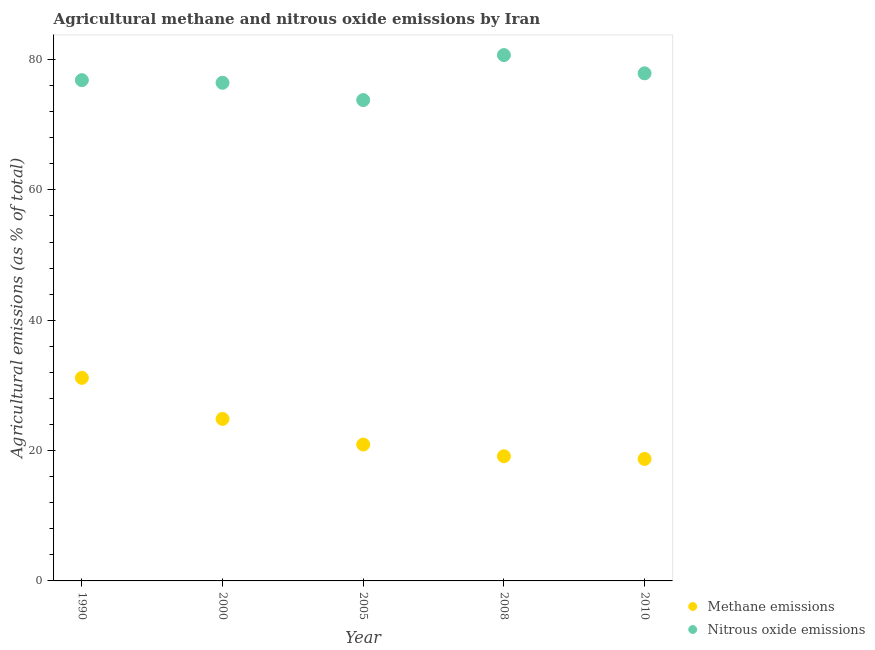What is the amount of nitrous oxide emissions in 2008?
Offer a very short reply. 80.69. Across all years, what is the maximum amount of methane emissions?
Your answer should be compact. 31.16. Across all years, what is the minimum amount of methane emissions?
Your response must be concise. 18.72. What is the total amount of nitrous oxide emissions in the graph?
Ensure brevity in your answer.  385.66. What is the difference between the amount of nitrous oxide emissions in 2008 and that in 2010?
Offer a terse response. 2.8. What is the difference between the amount of methane emissions in 2010 and the amount of nitrous oxide emissions in 2005?
Keep it short and to the point. -55.07. What is the average amount of methane emissions per year?
Your answer should be compact. 22.96. In the year 2005, what is the difference between the amount of methane emissions and amount of nitrous oxide emissions?
Offer a very short reply. -52.86. In how many years, is the amount of nitrous oxide emissions greater than 20 %?
Make the answer very short. 5. What is the ratio of the amount of methane emissions in 1990 to that in 2008?
Ensure brevity in your answer.  1.63. What is the difference between the highest and the second highest amount of nitrous oxide emissions?
Your answer should be very brief. 2.8. What is the difference between the highest and the lowest amount of methane emissions?
Provide a succinct answer. 12.44. Is the sum of the amount of nitrous oxide emissions in 1990 and 2010 greater than the maximum amount of methane emissions across all years?
Make the answer very short. Yes. Is the amount of methane emissions strictly greater than the amount of nitrous oxide emissions over the years?
Provide a short and direct response. No. Is the amount of nitrous oxide emissions strictly less than the amount of methane emissions over the years?
Offer a very short reply. No. How many years are there in the graph?
Provide a short and direct response. 5. What is the difference between two consecutive major ticks on the Y-axis?
Provide a short and direct response. 20. Are the values on the major ticks of Y-axis written in scientific E-notation?
Your response must be concise. No. Does the graph contain grids?
Make the answer very short. No. What is the title of the graph?
Keep it short and to the point. Agricultural methane and nitrous oxide emissions by Iran. Does "Agricultural land" appear as one of the legend labels in the graph?
Provide a short and direct response. No. What is the label or title of the X-axis?
Your answer should be compact. Year. What is the label or title of the Y-axis?
Offer a terse response. Agricultural emissions (as % of total). What is the Agricultural emissions (as % of total) in Methane emissions in 1990?
Provide a succinct answer. 31.16. What is the Agricultural emissions (as % of total) in Nitrous oxide emissions in 1990?
Provide a succinct answer. 76.84. What is the Agricultural emissions (as % of total) of Methane emissions in 2000?
Keep it short and to the point. 24.86. What is the Agricultural emissions (as % of total) in Nitrous oxide emissions in 2000?
Provide a succinct answer. 76.44. What is the Agricultural emissions (as % of total) of Methane emissions in 2005?
Your response must be concise. 20.93. What is the Agricultural emissions (as % of total) in Nitrous oxide emissions in 2005?
Provide a succinct answer. 73.79. What is the Agricultural emissions (as % of total) in Methane emissions in 2008?
Make the answer very short. 19.13. What is the Agricultural emissions (as % of total) of Nitrous oxide emissions in 2008?
Keep it short and to the point. 80.69. What is the Agricultural emissions (as % of total) of Methane emissions in 2010?
Your response must be concise. 18.72. What is the Agricultural emissions (as % of total) of Nitrous oxide emissions in 2010?
Make the answer very short. 77.89. Across all years, what is the maximum Agricultural emissions (as % of total) of Methane emissions?
Make the answer very short. 31.16. Across all years, what is the maximum Agricultural emissions (as % of total) of Nitrous oxide emissions?
Keep it short and to the point. 80.69. Across all years, what is the minimum Agricultural emissions (as % of total) in Methane emissions?
Keep it short and to the point. 18.72. Across all years, what is the minimum Agricultural emissions (as % of total) in Nitrous oxide emissions?
Ensure brevity in your answer.  73.79. What is the total Agricultural emissions (as % of total) in Methane emissions in the graph?
Your response must be concise. 114.8. What is the total Agricultural emissions (as % of total) of Nitrous oxide emissions in the graph?
Provide a succinct answer. 385.66. What is the difference between the Agricultural emissions (as % of total) in Methane emissions in 1990 and that in 2000?
Provide a short and direct response. 6.3. What is the difference between the Agricultural emissions (as % of total) in Nitrous oxide emissions in 1990 and that in 2000?
Give a very brief answer. 0.4. What is the difference between the Agricultural emissions (as % of total) in Methane emissions in 1990 and that in 2005?
Make the answer very short. 10.23. What is the difference between the Agricultural emissions (as % of total) of Nitrous oxide emissions in 1990 and that in 2005?
Provide a succinct answer. 3.06. What is the difference between the Agricultural emissions (as % of total) in Methane emissions in 1990 and that in 2008?
Your answer should be compact. 12.03. What is the difference between the Agricultural emissions (as % of total) of Nitrous oxide emissions in 1990 and that in 2008?
Make the answer very short. -3.85. What is the difference between the Agricultural emissions (as % of total) of Methane emissions in 1990 and that in 2010?
Give a very brief answer. 12.44. What is the difference between the Agricultural emissions (as % of total) in Nitrous oxide emissions in 1990 and that in 2010?
Ensure brevity in your answer.  -1.05. What is the difference between the Agricultural emissions (as % of total) in Methane emissions in 2000 and that in 2005?
Your answer should be compact. 3.94. What is the difference between the Agricultural emissions (as % of total) in Nitrous oxide emissions in 2000 and that in 2005?
Provide a short and direct response. 2.65. What is the difference between the Agricultural emissions (as % of total) in Methane emissions in 2000 and that in 2008?
Your answer should be compact. 5.73. What is the difference between the Agricultural emissions (as % of total) of Nitrous oxide emissions in 2000 and that in 2008?
Keep it short and to the point. -4.25. What is the difference between the Agricultural emissions (as % of total) in Methane emissions in 2000 and that in 2010?
Keep it short and to the point. 6.14. What is the difference between the Agricultural emissions (as % of total) in Nitrous oxide emissions in 2000 and that in 2010?
Your answer should be compact. -1.45. What is the difference between the Agricultural emissions (as % of total) in Methane emissions in 2005 and that in 2008?
Give a very brief answer. 1.8. What is the difference between the Agricultural emissions (as % of total) of Nitrous oxide emissions in 2005 and that in 2008?
Your answer should be compact. -6.91. What is the difference between the Agricultural emissions (as % of total) of Methane emissions in 2005 and that in 2010?
Provide a succinct answer. 2.2. What is the difference between the Agricultural emissions (as % of total) of Nitrous oxide emissions in 2005 and that in 2010?
Your response must be concise. -4.1. What is the difference between the Agricultural emissions (as % of total) of Methane emissions in 2008 and that in 2010?
Make the answer very short. 0.41. What is the difference between the Agricultural emissions (as % of total) of Nitrous oxide emissions in 2008 and that in 2010?
Offer a terse response. 2.8. What is the difference between the Agricultural emissions (as % of total) of Methane emissions in 1990 and the Agricultural emissions (as % of total) of Nitrous oxide emissions in 2000?
Your response must be concise. -45.28. What is the difference between the Agricultural emissions (as % of total) of Methane emissions in 1990 and the Agricultural emissions (as % of total) of Nitrous oxide emissions in 2005?
Keep it short and to the point. -42.63. What is the difference between the Agricultural emissions (as % of total) of Methane emissions in 1990 and the Agricultural emissions (as % of total) of Nitrous oxide emissions in 2008?
Offer a terse response. -49.53. What is the difference between the Agricultural emissions (as % of total) in Methane emissions in 1990 and the Agricultural emissions (as % of total) in Nitrous oxide emissions in 2010?
Keep it short and to the point. -46.73. What is the difference between the Agricultural emissions (as % of total) of Methane emissions in 2000 and the Agricultural emissions (as % of total) of Nitrous oxide emissions in 2005?
Provide a succinct answer. -48.93. What is the difference between the Agricultural emissions (as % of total) of Methane emissions in 2000 and the Agricultural emissions (as % of total) of Nitrous oxide emissions in 2008?
Make the answer very short. -55.83. What is the difference between the Agricultural emissions (as % of total) in Methane emissions in 2000 and the Agricultural emissions (as % of total) in Nitrous oxide emissions in 2010?
Give a very brief answer. -53.03. What is the difference between the Agricultural emissions (as % of total) of Methane emissions in 2005 and the Agricultural emissions (as % of total) of Nitrous oxide emissions in 2008?
Your answer should be compact. -59.77. What is the difference between the Agricultural emissions (as % of total) of Methane emissions in 2005 and the Agricultural emissions (as % of total) of Nitrous oxide emissions in 2010?
Offer a very short reply. -56.97. What is the difference between the Agricultural emissions (as % of total) of Methane emissions in 2008 and the Agricultural emissions (as % of total) of Nitrous oxide emissions in 2010?
Give a very brief answer. -58.76. What is the average Agricultural emissions (as % of total) of Methane emissions per year?
Offer a very short reply. 22.96. What is the average Agricultural emissions (as % of total) in Nitrous oxide emissions per year?
Your answer should be compact. 77.13. In the year 1990, what is the difference between the Agricultural emissions (as % of total) of Methane emissions and Agricultural emissions (as % of total) of Nitrous oxide emissions?
Your answer should be very brief. -45.68. In the year 2000, what is the difference between the Agricultural emissions (as % of total) in Methane emissions and Agricultural emissions (as % of total) in Nitrous oxide emissions?
Your answer should be very brief. -51.58. In the year 2005, what is the difference between the Agricultural emissions (as % of total) in Methane emissions and Agricultural emissions (as % of total) in Nitrous oxide emissions?
Your answer should be very brief. -52.86. In the year 2008, what is the difference between the Agricultural emissions (as % of total) of Methane emissions and Agricultural emissions (as % of total) of Nitrous oxide emissions?
Your response must be concise. -61.56. In the year 2010, what is the difference between the Agricultural emissions (as % of total) in Methane emissions and Agricultural emissions (as % of total) in Nitrous oxide emissions?
Ensure brevity in your answer.  -59.17. What is the ratio of the Agricultural emissions (as % of total) of Methane emissions in 1990 to that in 2000?
Give a very brief answer. 1.25. What is the ratio of the Agricultural emissions (as % of total) of Nitrous oxide emissions in 1990 to that in 2000?
Your answer should be very brief. 1.01. What is the ratio of the Agricultural emissions (as % of total) in Methane emissions in 1990 to that in 2005?
Provide a short and direct response. 1.49. What is the ratio of the Agricultural emissions (as % of total) in Nitrous oxide emissions in 1990 to that in 2005?
Offer a terse response. 1.04. What is the ratio of the Agricultural emissions (as % of total) in Methane emissions in 1990 to that in 2008?
Make the answer very short. 1.63. What is the ratio of the Agricultural emissions (as % of total) of Nitrous oxide emissions in 1990 to that in 2008?
Offer a very short reply. 0.95. What is the ratio of the Agricultural emissions (as % of total) of Methane emissions in 1990 to that in 2010?
Give a very brief answer. 1.66. What is the ratio of the Agricultural emissions (as % of total) in Nitrous oxide emissions in 1990 to that in 2010?
Your answer should be very brief. 0.99. What is the ratio of the Agricultural emissions (as % of total) of Methane emissions in 2000 to that in 2005?
Offer a terse response. 1.19. What is the ratio of the Agricultural emissions (as % of total) of Nitrous oxide emissions in 2000 to that in 2005?
Your response must be concise. 1.04. What is the ratio of the Agricultural emissions (as % of total) of Methane emissions in 2000 to that in 2008?
Ensure brevity in your answer.  1.3. What is the ratio of the Agricultural emissions (as % of total) of Nitrous oxide emissions in 2000 to that in 2008?
Offer a very short reply. 0.95. What is the ratio of the Agricultural emissions (as % of total) of Methane emissions in 2000 to that in 2010?
Your answer should be compact. 1.33. What is the ratio of the Agricultural emissions (as % of total) of Nitrous oxide emissions in 2000 to that in 2010?
Ensure brevity in your answer.  0.98. What is the ratio of the Agricultural emissions (as % of total) in Methane emissions in 2005 to that in 2008?
Ensure brevity in your answer.  1.09. What is the ratio of the Agricultural emissions (as % of total) of Nitrous oxide emissions in 2005 to that in 2008?
Your response must be concise. 0.91. What is the ratio of the Agricultural emissions (as % of total) in Methane emissions in 2005 to that in 2010?
Give a very brief answer. 1.12. What is the ratio of the Agricultural emissions (as % of total) of Nitrous oxide emissions in 2005 to that in 2010?
Provide a short and direct response. 0.95. What is the ratio of the Agricultural emissions (as % of total) of Methane emissions in 2008 to that in 2010?
Offer a terse response. 1.02. What is the ratio of the Agricultural emissions (as % of total) of Nitrous oxide emissions in 2008 to that in 2010?
Keep it short and to the point. 1.04. What is the difference between the highest and the second highest Agricultural emissions (as % of total) in Methane emissions?
Ensure brevity in your answer.  6.3. What is the difference between the highest and the second highest Agricultural emissions (as % of total) in Nitrous oxide emissions?
Your answer should be compact. 2.8. What is the difference between the highest and the lowest Agricultural emissions (as % of total) of Methane emissions?
Offer a very short reply. 12.44. What is the difference between the highest and the lowest Agricultural emissions (as % of total) of Nitrous oxide emissions?
Your answer should be compact. 6.91. 